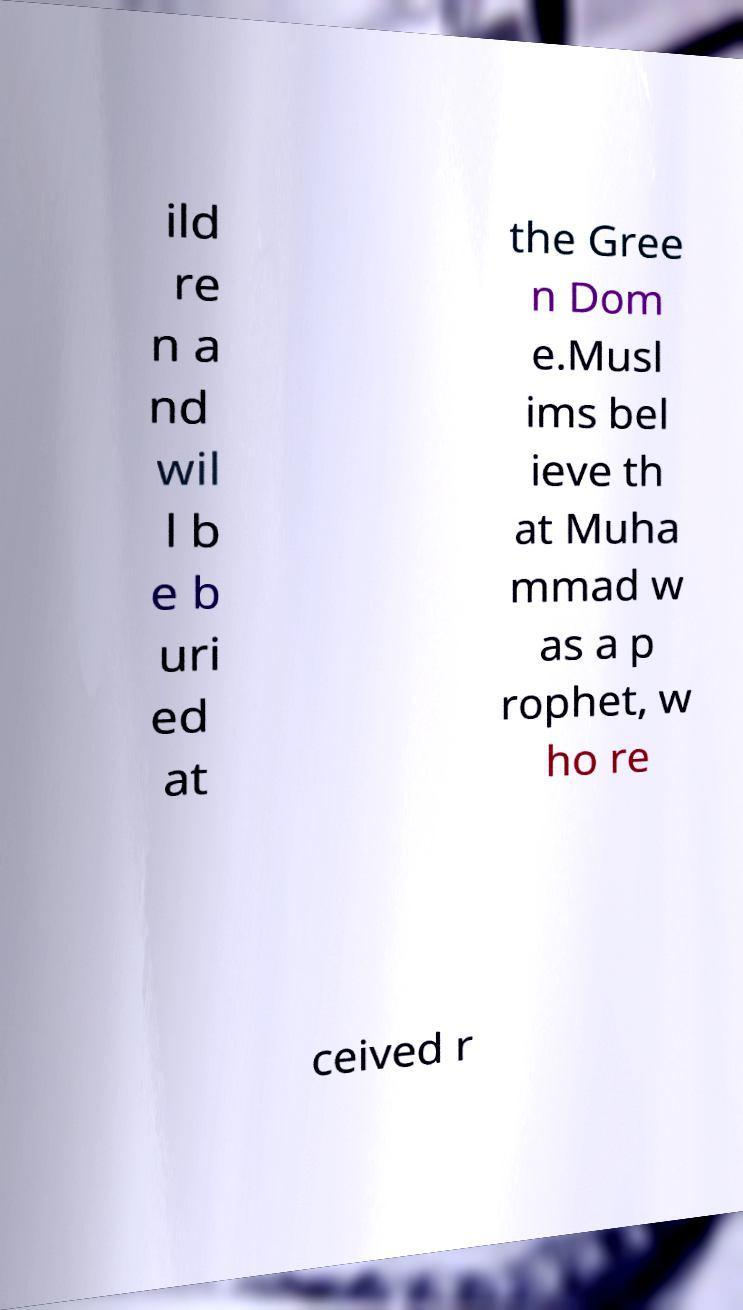For documentation purposes, I need the text within this image transcribed. Could you provide that? ild re n a nd wil l b e b uri ed at the Gree n Dom e.Musl ims bel ieve th at Muha mmad w as a p rophet, w ho re ceived r 